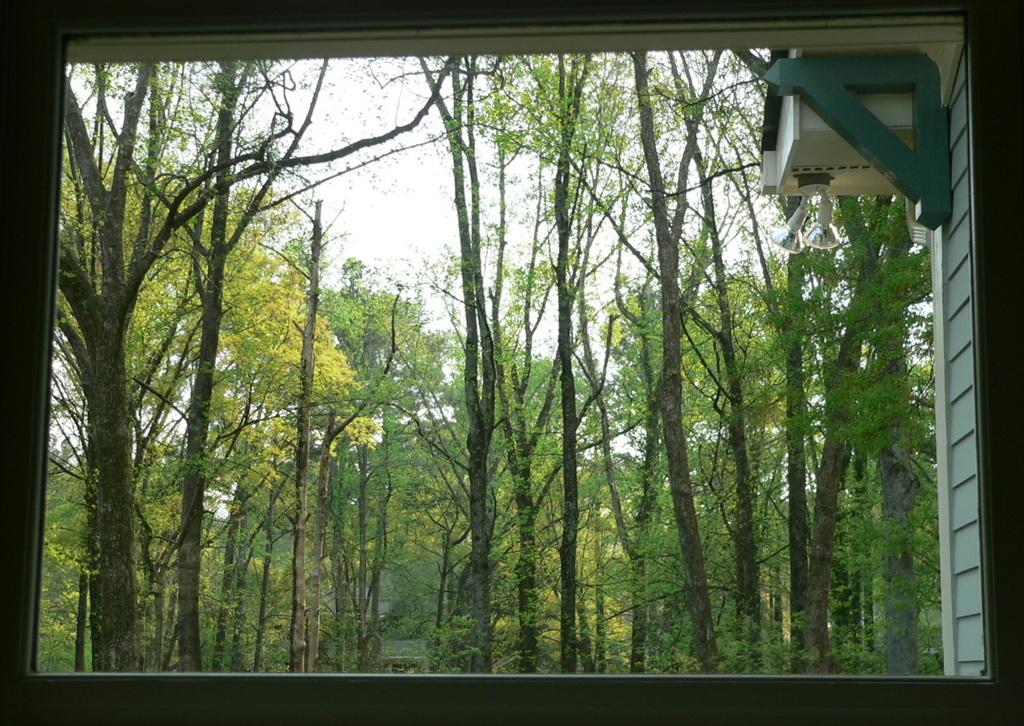What type of transparent barrier is present in the image? There is a glass window in the image. What can be seen through the glass window? Trees are visible through the window. What is visible in the background of the image? There is a wall, lights, and the sky visible in the background. Is there a veil covering the trees in the image? No, there is no veil present in the image. What type of polish is being applied to the lights in the background? There is no indication of any polish being applied to the lights in the image. 